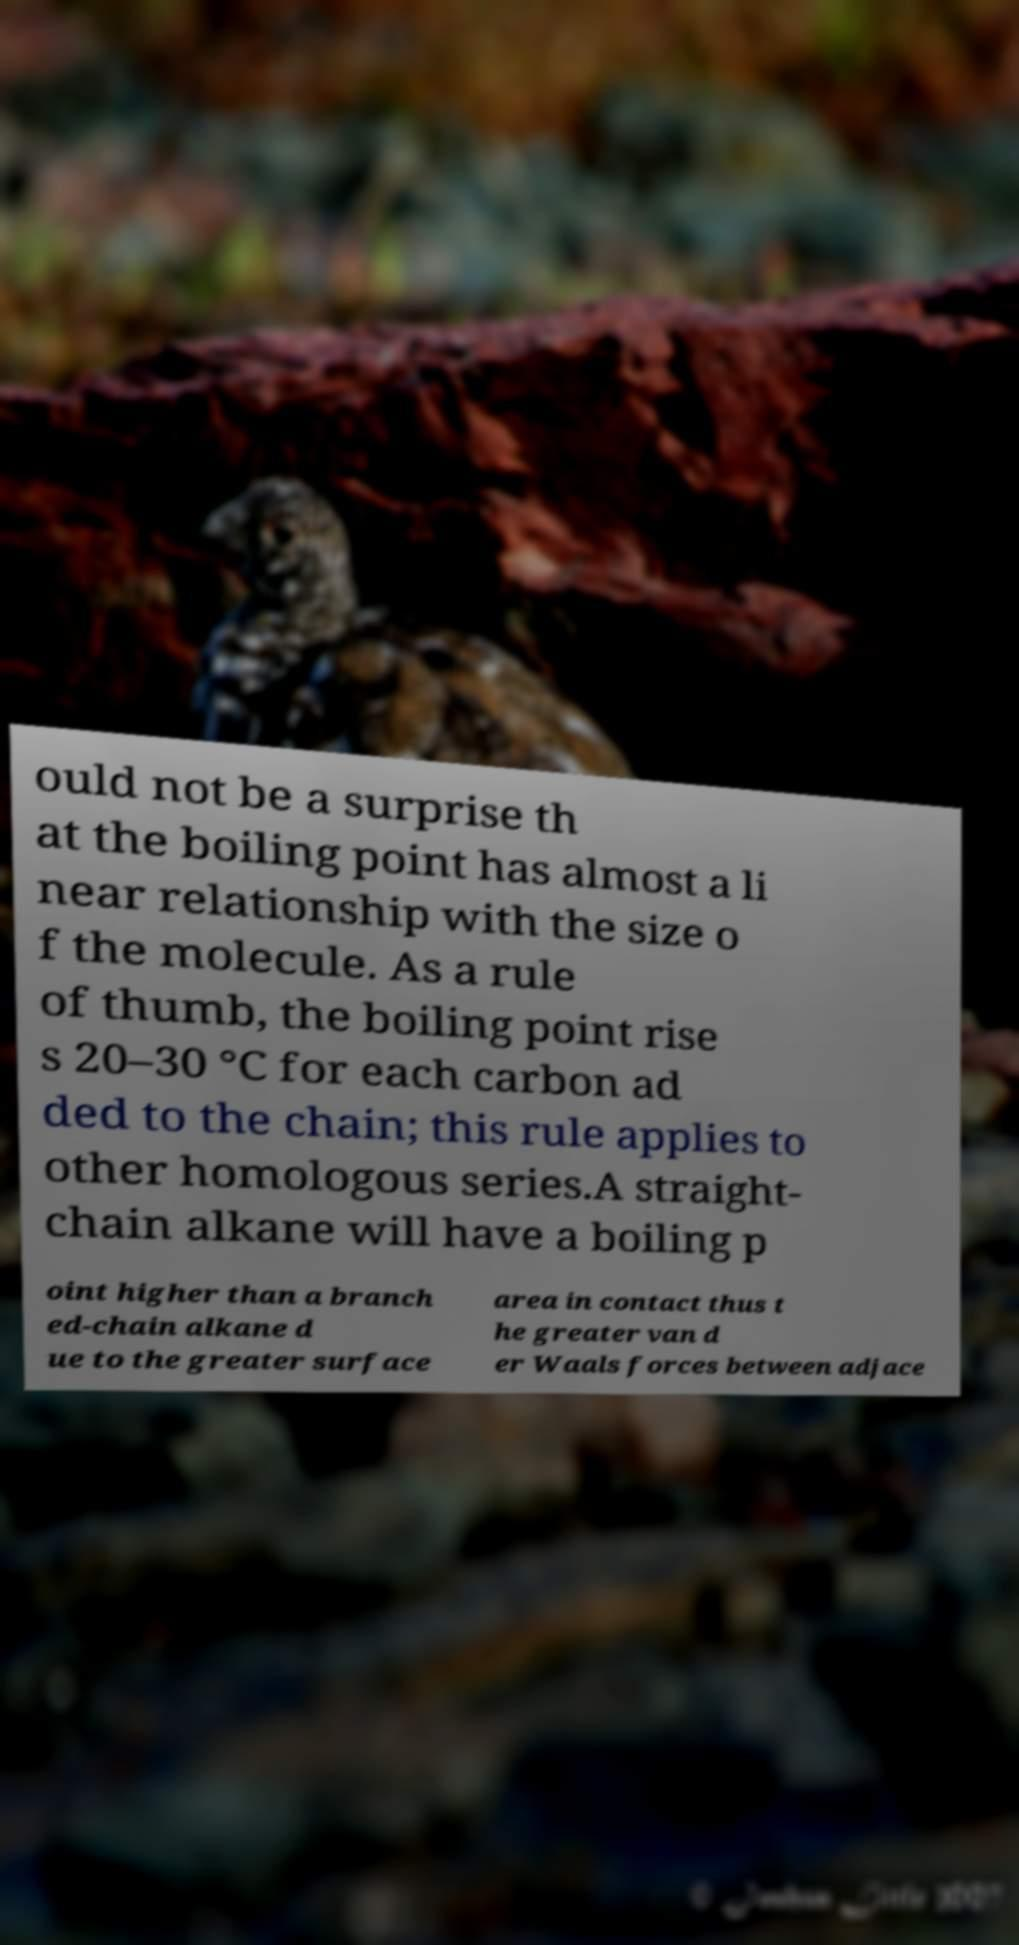There's text embedded in this image that I need extracted. Can you transcribe it verbatim? ould not be a surprise th at the boiling point has almost a li near relationship with the size o f the molecule. As a rule of thumb, the boiling point rise s 20–30 °C for each carbon ad ded to the chain; this rule applies to other homologous series.A straight- chain alkane will have a boiling p oint higher than a branch ed-chain alkane d ue to the greater surface area in contact thus t he greater van d er Waals forces between adjace 